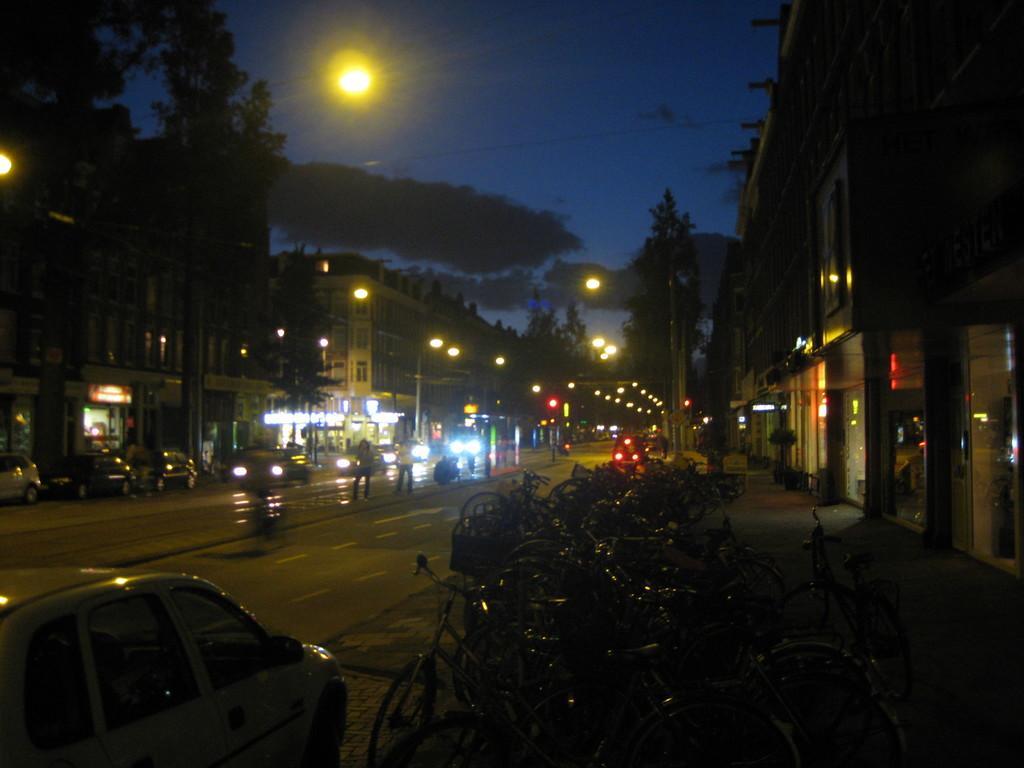Please provide a concise description of this image. In the foreground of the image we can see a car, bicycle and road. In the middle of the image we can see buildings, some persons are walking on the road and lights are there. On the top we can see the sky. 